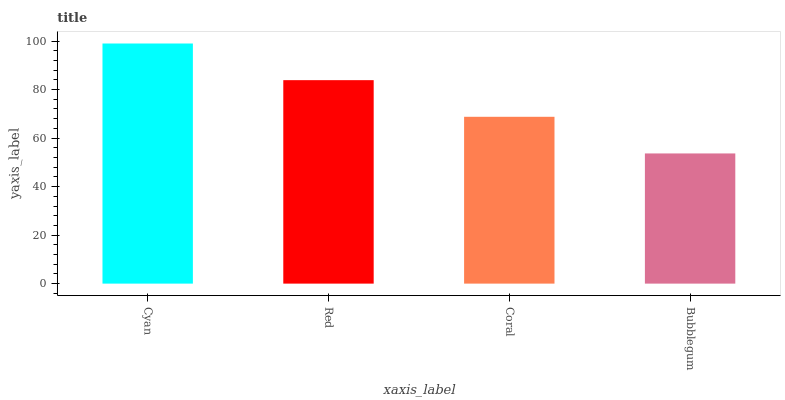Is Bubblegum the minimum?
Answer yes or no. Yes. Is Cyan the maximum?
Answer yes or no. Yes. Is Red the minimum?
Answer yes or no. No. Is Red the maximum?
Answer yes or no. No. Is Cyan greater than Red?
Answer yes or no. Yes. Is Red less than Cyan?
Answer yes or no. Yes. Is Red greater than Cyan?
Answer yes or no. No. Is Cyan less than Red?
Answer yes or no. No. Is Red the high median?
Answer yes or no. Yes. Is Coral the low median?
Answer yes or no. Yes. Is Coral the high median?
Answer yes or no. No. Is Cyan the low median?
Answer yes or no. No. 